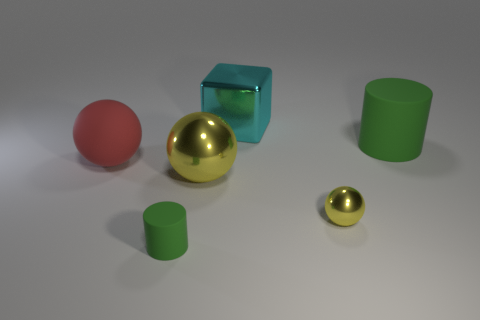Is there anything else that has the same shape as the cyan object?
Offer a terse response. No. How big is the metal object behind the green cylinder that is behind the large matte sphere?
Provide a succinct answer. Large. How many things are green rubber things or gray metal blocks?
Offer a very short reply. 2. Is there a big metallic ball that has the same color as the small metal object?
Your response must be concise. Yes. Are there fewer red rubber balls than large rubber things?
Give a very brief answer. Yes. How many objects are either big shiny spheres or metallic objects on the left side of the tiny metal ball?
Ensure brevity in your answer.  2. Are there any big red spheres made of the same material as the tiny green cylinder?
Provide a short and direct response. Yes. There is a cube that is the same size as the red sphere; what is it made of?
Keep it short and to the point. Metal. What material is the big thing left of the small cylinder to the left of the cyan cube?
Keep it short and to the point. Rubber. Is the shape of the big rubber thing behind the red object the same as  the tiny green matte thing?
Your answer should be compact. Yes. 